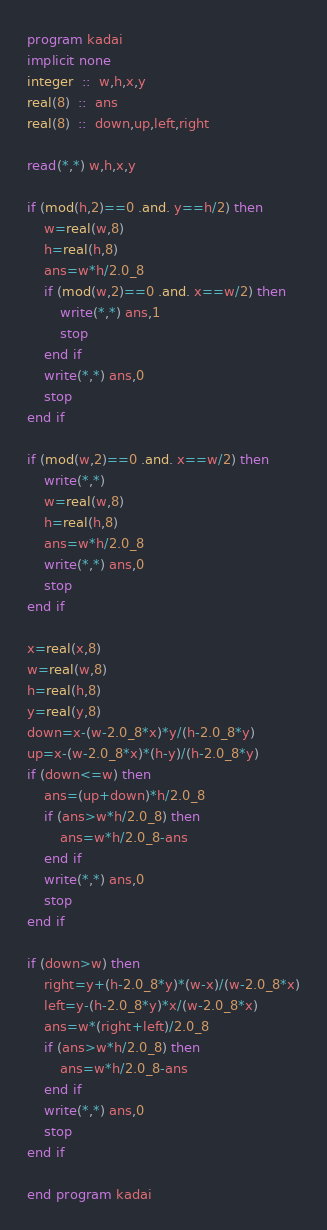<code> <loc_0><loc_0><loc_500><loc_500><_FORTRAN_>program kadai
implicit none
integer  ::  w,h,x,y
real(8)  ::  ans
real(8)  ::  down,up,left,right

read(*,*) w,h,x,y

if (mod(h,2)==0 .and. y==h/2) then
    w=real(w,8)
    h=real(h,8)
    ans=w*h/2.0_8
    if (mod(w,2)==0 .and. x==w/2) then
        write(*,*) ans,1
        stop
    end if
    write(*,*) ans,0
    stop
end if

if (mod(w,2)==0 .and. x==w/2) then
    write(*,*)
    w=real(w,8)
    h=real(h,8)
    ans=w*h/2.0_8
    write(*,*) ans,0
    stop
end if

x=real(x,8)
w=real(w,8)
h=real(h,8)
y=real(y,8)
down=x-(w-2.0_8*x)*y/(h-2.0_8*y)
up=x-(w-2.0_8*x)*(h-y)/(h-2.0_8*y)
if (down<=w) then
    ans=(up+down)*h/2.0_8
    if (ans>w*h/2.0_8) then
        ans=w*h/2.0_8-ans
    end if
    write(*,*) ans,0
    stop
end if

if (down>w) then
    right=y+(h-2.0_8*y)*(w-x)/(w-2.0_8*x)
    left=y-(h-2.0_8*y)*x/(w-2.0_8*x)
    ans=w*(right+left)/2.0_8
    if (ans>w*h/2.0_8) then
        ans=w*h/2.0_8-ans
    end if
    write(*,*) ans,0
    stop
end if

end program kadai</code> 